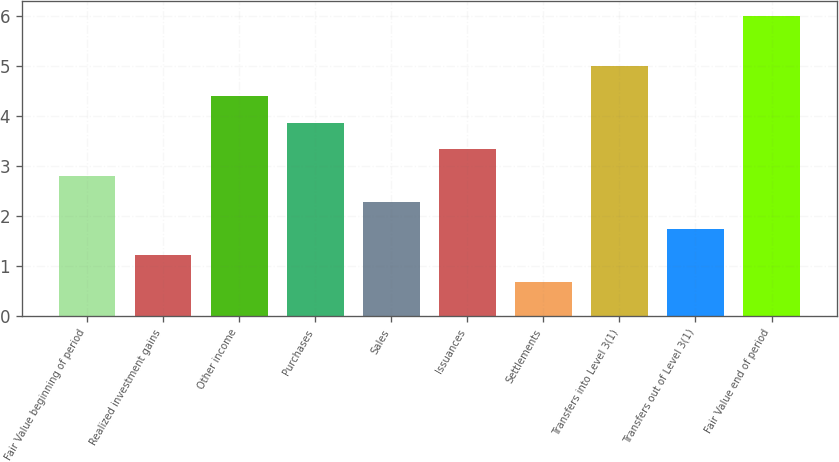<chart> <loc_0><loc_0><loc_500><loc_500><bar_chart><fcel>Fair Value beginning of period<fcel>Realized investment gains<fcel>Other income<fcel>Purchases<fcel>Sales<fcel>Issuances<fcel>Settlements<fcel>Transfers into Level 3(1)<fcel>Transfers out of Level 3(1)<fcel>Fair Value end of period<nl><fcel>2.8<fcel>1.21<fcel>4.39<fcel>3.86<fcel>2.27<fcel>3.33<fcel>0.68<fcel>5<fcel>1.74<fcel>6<nl></chart> 